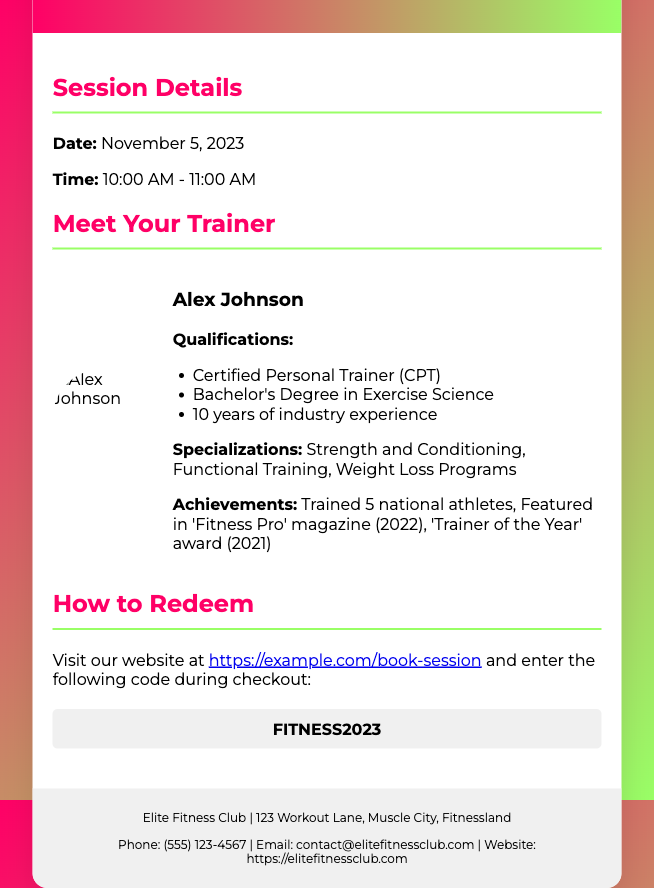What is the date of the training session? The date of the training session is explicitly mentioned in the document.
Answer: November 5, 2023 What time does the training session start? The starting time for the training session is stated in the document.
Answer: 10:00 AM Who is the trainer for the session? The trainer's name is highlighted in the document.
Answer: Alex Johnson What are Alex Johnson’s specializations? The document lists the trainer's specializations under their profile section.
Answer: Strength and Conditioning, Functional Training, Weight Loss Programs What code do I use to redeem the voucher? The redeemable code is specifically provided in the document.
Answer: FITNESS2023 How many years of experience does Alex Johnson have? The document mentions the years of experience of the trainer.
Answer: 10 years Where can I redeem this gift voucher? The document specifies the website where the voucher can be redeemed.
Answer: https://example.com/book-session What award did Alex Johnson receive in 2021? The document mentions an achievement for the trainer regarding an award.
Answer: 'Trainer of the Year' award What degree does Alex Johnson hold? The document indicates the educational qualifications of the trainer.
Answer: Bachelor's Degree in Exercise Science 